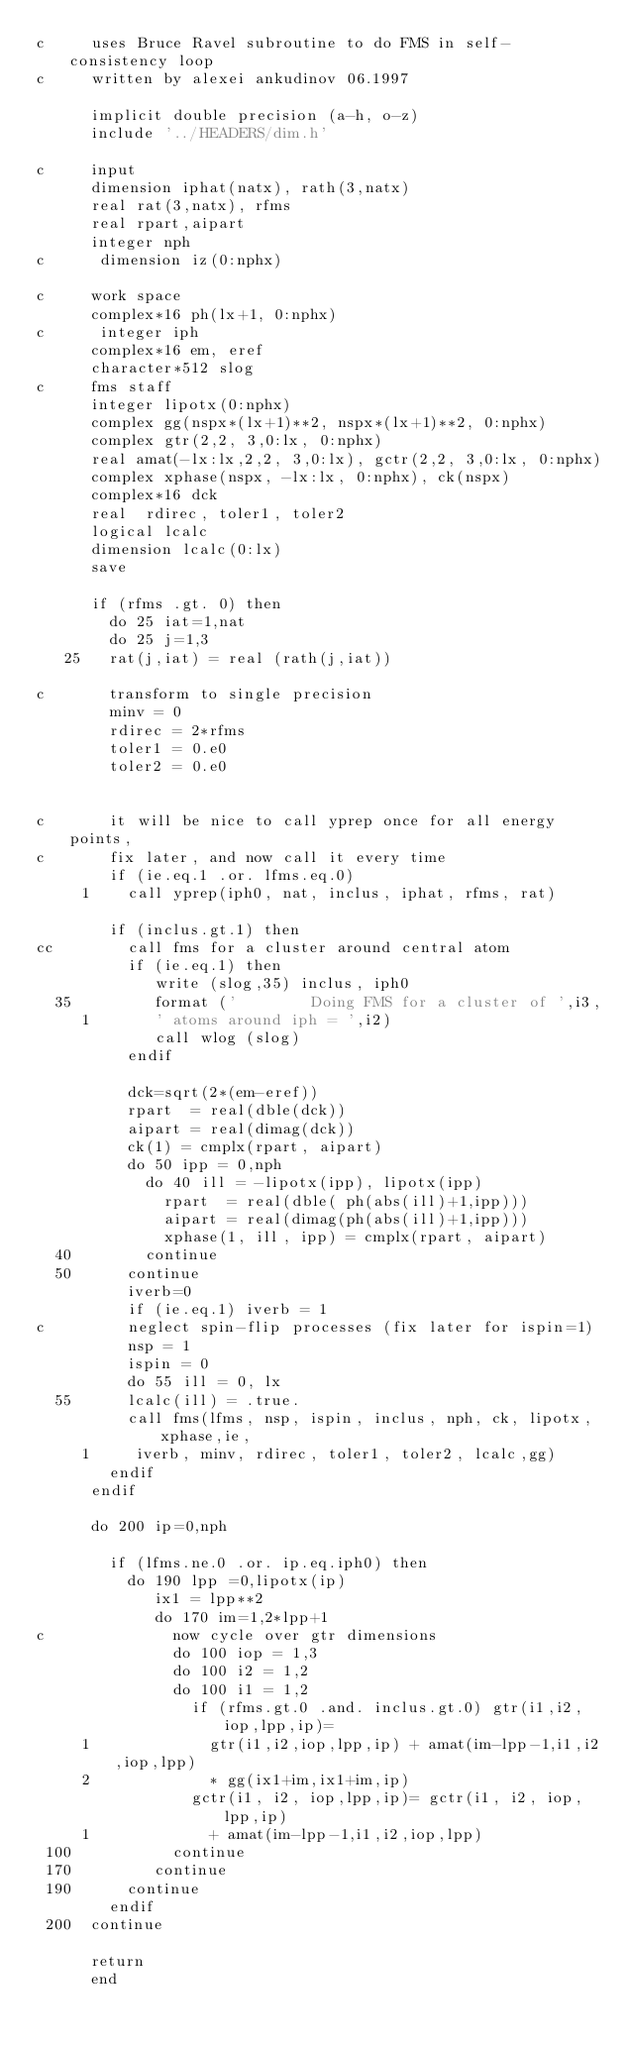Convert code to text. <code><loc_0><loc_0><loc_500><loc_500><_FORTRAN_>c     uses Bruce Ravel subroutine to do FMS in self-consistency loop
c     written by alexei ankudinov 06.1997

      implicit double precision (a-h, o-z)
      include '../HEADERS/dim.h'

c     input
      dimension iphat(natx), rath(3,natx)
      real rat(3,natx), rfms
      real rpart,aipart
      integer nph
c      dimension iz(0:nphx)

c     work space
      complex*16 ph(lx+1, 0:nphx)
c      integer iph
      complex*16 em, eref
      character*512 slog
c     fms staff
      integer lipotx(0:nphx)
      complex gg(nspx*(lx+1)**2, nspx*(lx+1)**2, 0:nphx)
      complex gtr(2,2, 3,0:lx, 0:nphx)
      real amat(-lx:lx,2,2, 3,0:lx), gctr(2,2, 3,0:lx, 0:nphx)
      complex xphase(nspx, -lx:lx, 0:nphx), ck(nspx)
      complex*16 dck
      real  rdirec, toler1, toler2
      logical lcalc
      dimension lcalc(0:lx)
      save

      if (rfms .gt. 0) then
        do 25 iat=1,nat
        do 25 j=1,3
   25   rat(j,iat) = real (rath(j,iat))

c       transform to single precision
        minv = 0
        rdirec = 2*rfms
        toler1 = 0.e0
        toler2 = 0.e0


c       it will be nice to call yprep once for all energy points,
c       fix later, and now call it every time
        if (ie.eq.1 .or. lfms.eq.0) 
     1    call yprep(iph0, nat, inclus, iphat, rfms, rat)

        if (inclus.gt.1) then
cc        call fms for a cluster around central atom
          if (ie.eq.1) then
             write (slog,35) inclus, iph0
  35         format ('        Doing FMS for a cluster of ',i3,
     1       ' atoms around iph = ',i2)
             call wlog (slog)
          endif

          dck=sqrt(2*(em-eref))
          rpart  = real(dble(dck))
          aipart = real(dimag(dck))
          ck(1) = cmplx(rpart, aipart)
          do 50 ipp = 0,nph
            do 40 ill = -lipotx(ipp), lipotx(ipp)
              rpart  = real(dble( ph(abs(ill)+1,ipp)))
              aipart = real(dimag(ph(abs(ill)+1,ipp)))
              xphase(1, ill, ipp) = cmplx(rpart, aipart)
  40        continue
  50      continue
          iverb=0
          if (ie.eq.1) iverb = 1
c         neglect spin-flip processes (fix later for ispin=1)
          nsp = 1
          ispin = 0
          do 55 ill = 0, lx
  55      lcalc(ill) = .true.
          call fms(lfms, nsp, ispin, inclus, nph, ck, lipotx, xphase,ie,
     1     iverb, minv, rdirec, toler1, toler2, lcalc,gg)
        endif
      endif

      do 200 ip=0,nph

        if (lfms.ne.0 .or. ip.eq.iph0) then
          do 190 lpp =0,lipotx(ip)
             ix1 = lpp**2 
             do 170 im=1,2*lpp+1
c              now cycle over gtr dimensions
               do 100 iop = 1,3
               do 100 i2 = 1,2
               do 100 i1 = 1,2
                 if (rfms.gt.0 .and. inclus.gt.0) gtr(i1,i2,iop,lpp,ip)= 
     1             gtr(i1,i2,iop,lpp,ip) + amat(im-lpp-1,i1,i2,iop,lpp)
     2             * gg(ix1+im,ix1+im,ip)
                 gctr(i1, i2, iop,lpp,ip)= gctr(i1, i2, iop,lpp,ip)
     1             + amat(im-lpp-1,i1,i2,iop,lpp)
 100           continue
 170         continue
 190      continue
        endif
 200  continue

      return
      end
</code> 